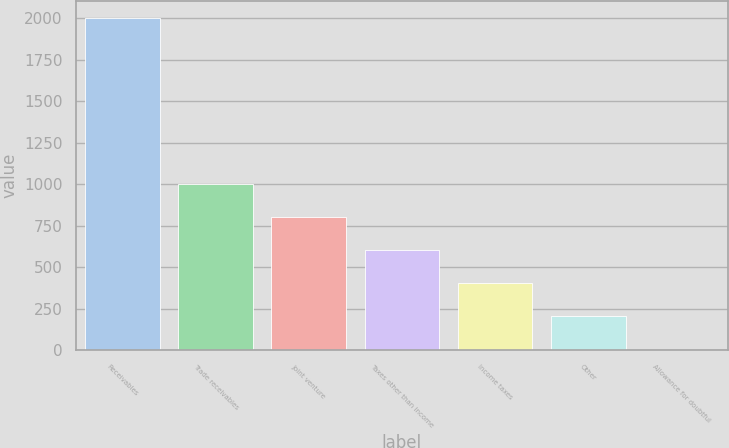<chart> <loc_0><loc_0><loc_500><loc_500><bar_chart><fcel>Receivables<fcel>Trade receivables<fcel>Joint venture<fcel>Taxes other than income<fcel>Income taxes<fcel>Other<fcel>Allowance for doubtful<nl><fcel>2003<fcel>1003.9<fcel>804.08<fcel>604.26<fcel>404.44<fcel>204.62<fcel>4.8<nl></chart> 